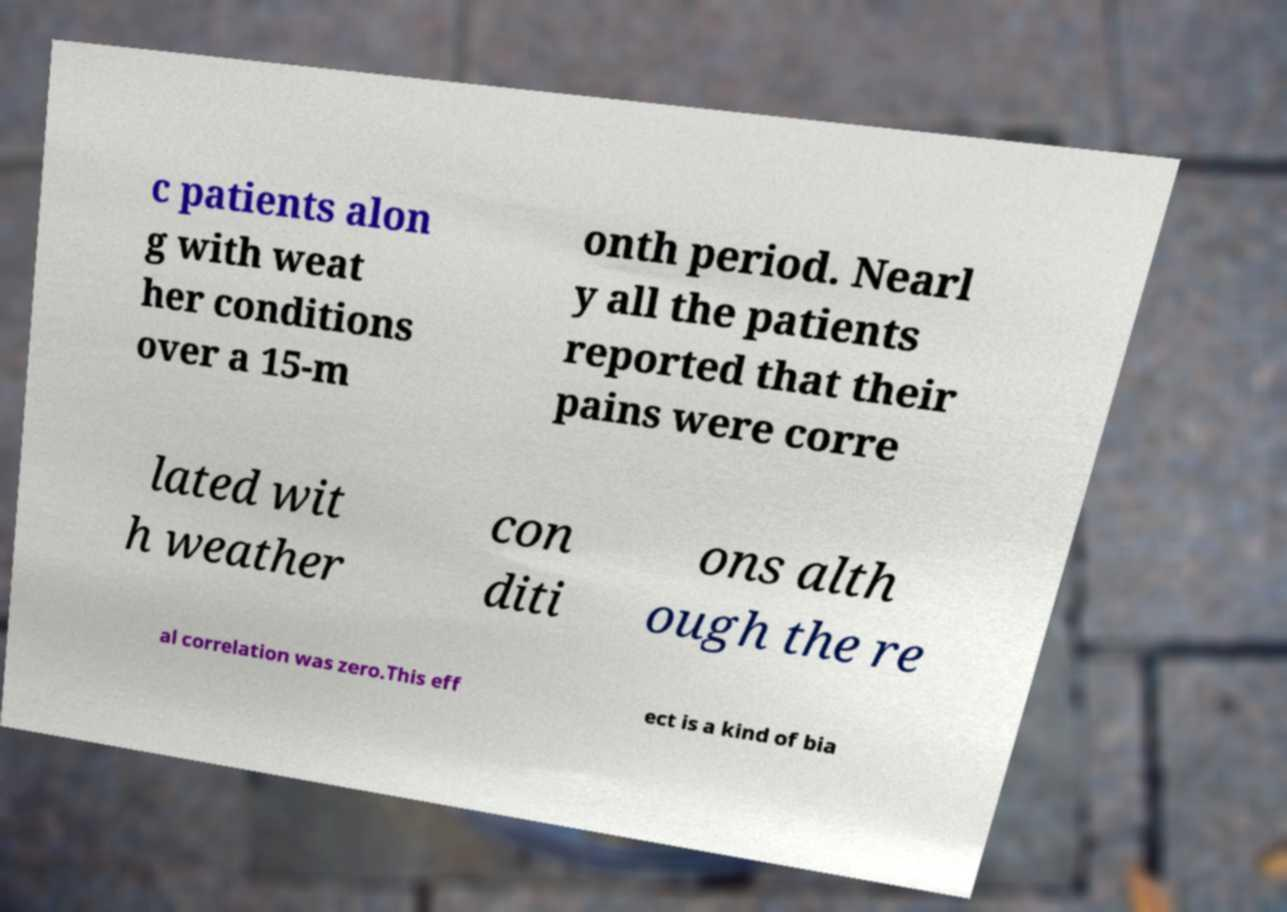Please identify and transcribe the text found in this image. c patients alon g with weat her conditions over a 15-m onth period. Nearl y all the patients reported that their pains were corre lated wit h weather con diti ons alth ough the re al correlation was zero.This eff ect is a kind of bia 